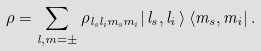<formula> <loc_0><loc_0><loc_500><loc_500>\rho = \sum _ { l , m = \pm } \rho _ { l _ { s } l _ { i } m _ { s } m _ { i } } | \, l _ { s } , l _ { i } \, \rangle \left \langle m _ { s } , m _ { i } \right | .</formula> 